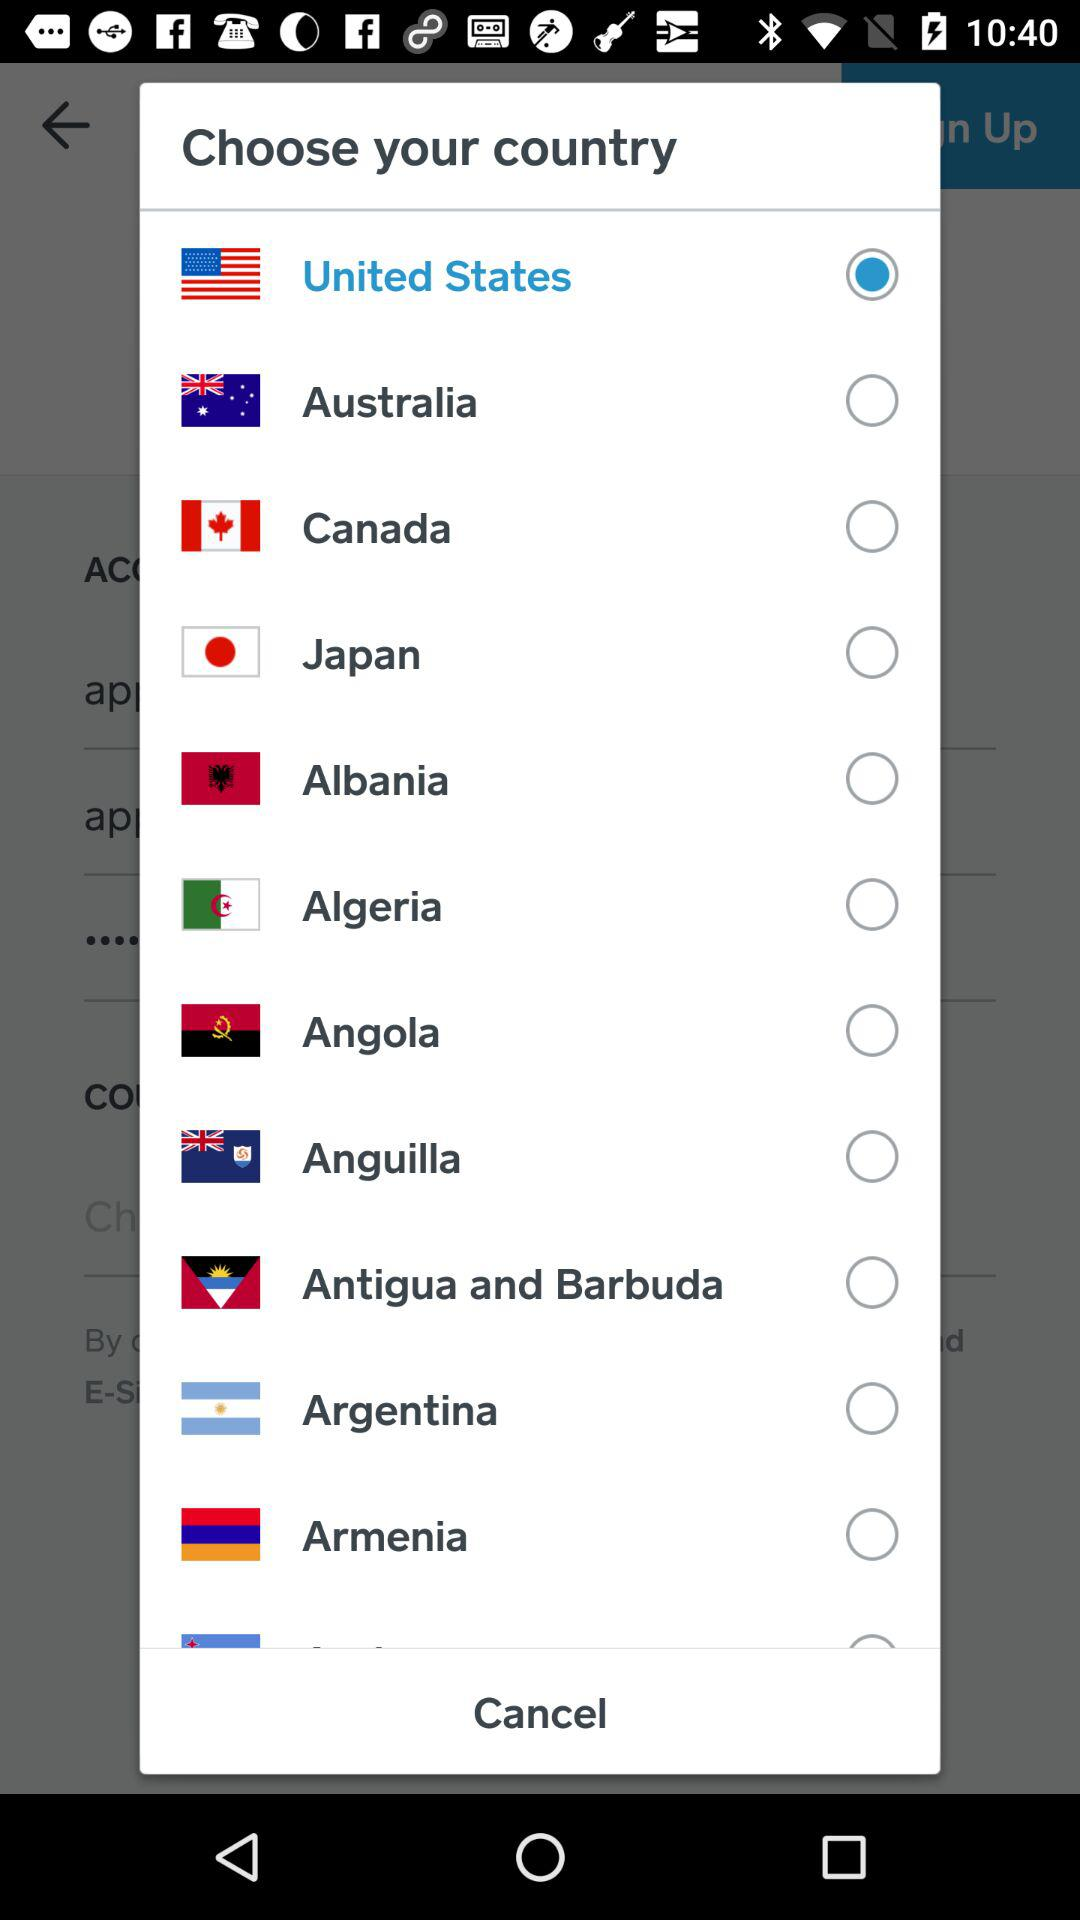What are the countries that I can select? You can select the countries that are the United States, Australia, Canada, Japan, Albania, Algeria, Angola, Anguilla, Antigua and Barbuda, Argentina and Armenia. 